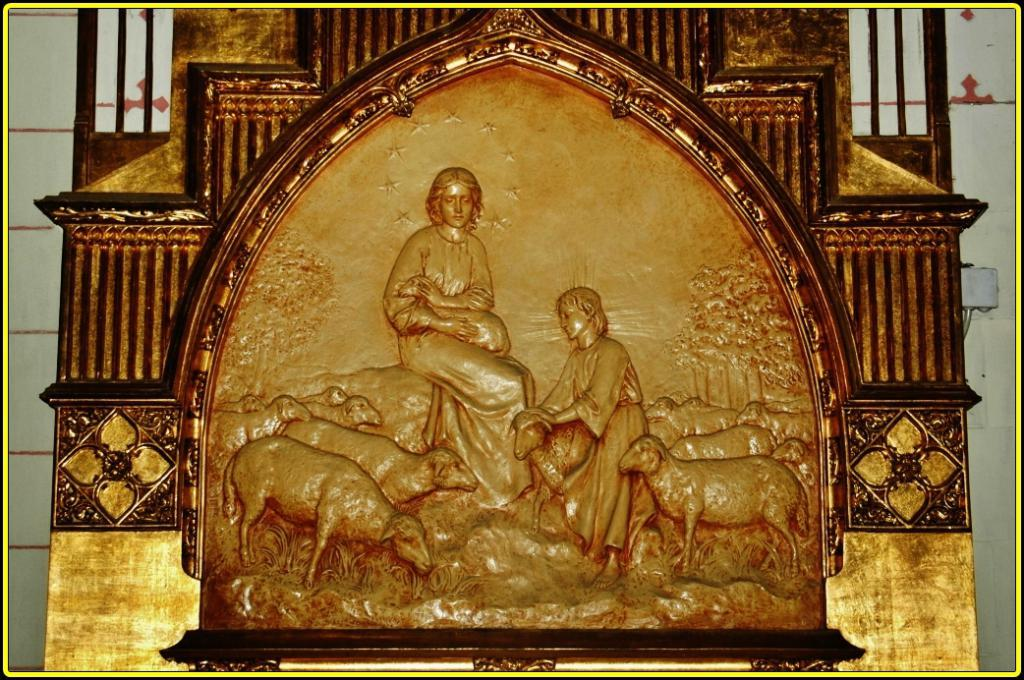What is on the wall in the image? There is a sculpture on a wall in the image. What is the subject of the sculpture? The sculpture features a group of animals. Are there any human figures in the sculpture? Yes, there are two people depicted in the sculpture. What type of juice is being served in the cave depicted in the sculpture? There is no cave or juice present in the image; the sculpture features a group of animals and two people. 